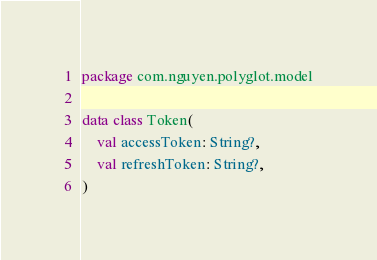Convert code to text. <code><loc_0><loc_0><loc_500><loc_500><_Kotlin_>package com.nguyen.polyglot.model

data class Token(
    val accessToken: String?,
    val refreshToken: String?,
)
</code> 